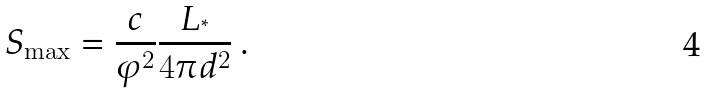Convert formula to latex. <formula><loc_0><loc_0><loc_500><loc_500>S _ { \max } = \frac { c } { \varphi ^ { 2 } } \frac { L _ { ^ { * } } } { 4 \pi d ^ { 2 } } \, .</formula> 